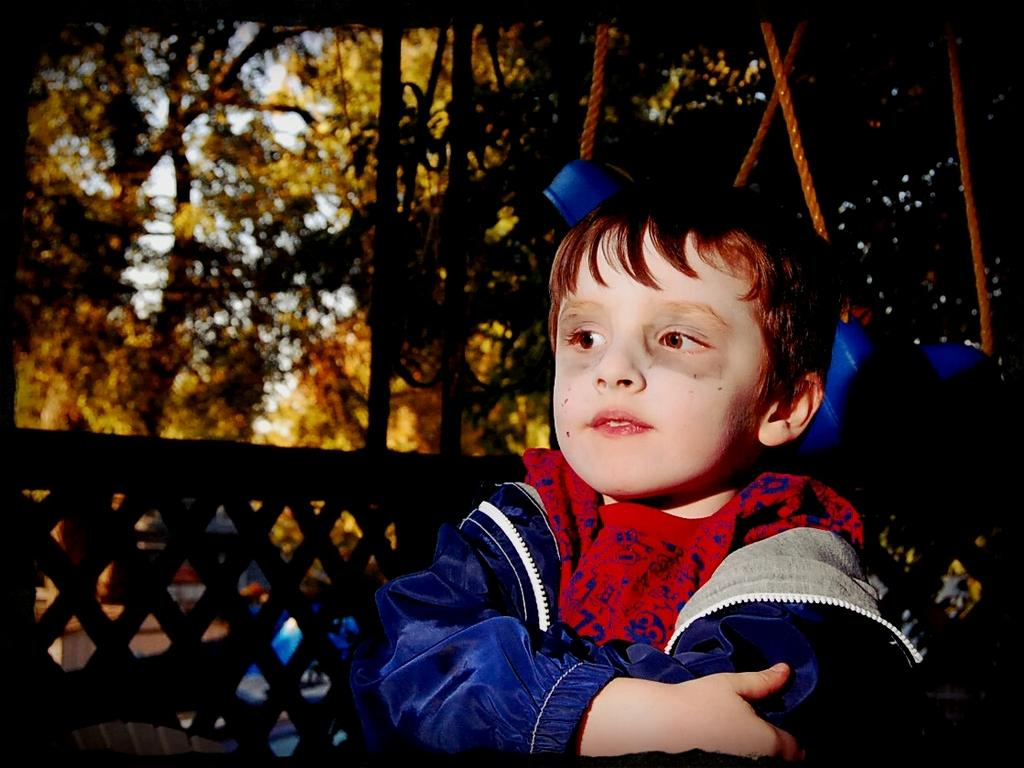Who is the main subject in the image? There is a boy in the image. What can be seen in the background of the image? Trees are visible in the image. What type of barrier is present in the image? There is a wooden fence in the image. What color is the boy's jacket in the image? The boy is wearing a blue jacket. What type of loaf is the boy holding in the image? There is no loaf present in the image; the boy is not holding anything. 